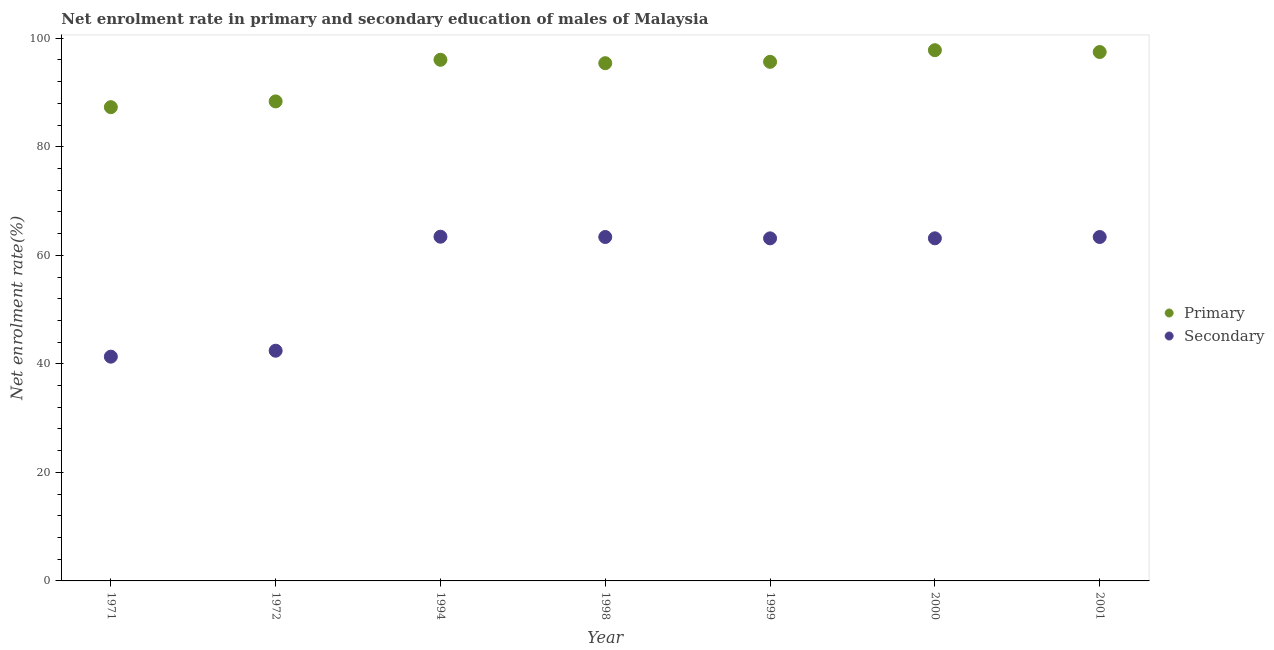Is the number of dotlines equal to the number of legend labels?
Provide a succinct answer. Yes. What is the enrollment rate in primary education in 1994?
Provide a short and direct response. 96.03. Across all years, what is the maximum enrollment rate in primary education?
Ensure brevity in your answer.  97.8. Across all years, what is the minimum enrollment rate in secondary education?
Your answer should be compact. 41.32. In which year was the enrollment rate in secondary education minimum?
Your answer should be very brief. 1971. What is the total enrollment rate in secondary education in the graph?
Offer a terse response. 400.18. What is the difference between the enrollment rate in primary education in 1972 and that in 1999?
Offer a very short reply. -7.29. What is the difference between the enrollment rate in secondary education in 1972 and the enrollment rate in primary education in 1994?
Your answer should be compact. -53.61. What is the average enrollment rate in primary education per year?
Give a very brief answer. 94. In the year 2001, what is the difference between the enrollment rate in primary education and enrollment rate in secondary education?
Keep it short and to the point. 34.09. What is the ratio of the enrollment rate in primary education in 1994 to that in 2001?
Give a very brief answer. 0.99. Is the enrollment rate in primary education in 1972 less than that in 1999?
Keep it short and to the point. Yes. Is the difference between the enrollment rate in primary education in 1998 and 1999 greater than the difference between the enrollment rate in secondary education in 1998 and 1999?
Ensure brevity in your answer.  No. What is the difference between the highest and the second highest enrollment rate in primary education?
Your answer should be compact. 0.34. What is the difference between the highest and the lowest enrollment rate in primary education?
Provide a short and direct response. 10.5. Does the graph contain any zero values?
Offer a terse response. No. Does the graph contain grids?
Provide a succinct answer. No. Where does the legend appear in the graph?
Offer a very short reply. Center right. How many legend labels are there?
Ensure brevity in your answer.  2. How are the legend labels stacked?
Your answer should be compact. Vertical. What is the title of the graph?
Give a very brief answer. Net enrolment rate in primary and secondary education of males of Malaysia. Does "Urban Population" appear as one of the legend labels in the graph?
Provide a short and direct response. No. What is the label or title of the X-axis?
Make the answer very short. Year. What is the label or title of the Y-axis?
Provide a short and direct response. Net enrolment rate(%). What is the Net enrolment rate(%) of Primary in 1971?
Keep it short and to the point. 87.3. What is the Net enrolment rate(%) of Secondary in 1971?
Offer a terse response. 41.32. What is the Net enrolment rate(%) in Primary in 1972?
Offer a terse response. 88.36. What is the Net enrolment rate(%) in Secondary in 1972?
Provide a succinct answer. 42.42. What is the Net enrolment rate(%) of Primary in 1994?
Offer a very short reply. 96.03. What is the Net enrolment rate(%) of Secondary in 1994?
Your answer should be compact. 63.43. What is the Net enrolment rate(%) of Primary in 1998?
Keep it short and to the point. 95.4. What is the Net enrolment rate(%) of Secondary in 1998?
Offer a very short reply. 63.38. What is the Net enrolment rate(%) of Primary in 1999?
Offer a terse response. 95.65. What is the Net enrolment rate(%) in Secondary in 1999?
Keep it short and to the point. 63.13. What is the Net enrolment rate(%) of Primary in 2000?
Give a very brief answer. 97.8. What is the Net enrolment rate(%) in Secondary in 2000?
Your answer should be compact. 63.13. What is the Net enrolment rate(%) in Primary in 2001?
Provide a succinct answer. 97.46. What is the Net enrolment rate(%) of Secondary in 2001?
Ensure brevity in your answer.  63.37. Across all years, what is the maximum Net enrolment rate(%) of Primary?
Give a very brief answer. 97.8. Across all years, what is the maximum Net enrolment rate(%) of Secondary?
Keep it short and to the point. 63.43. Across all years, what is the minimum Net enrolment rate(%) of Primary?
Keep it short and to the point. 87.3. Across all years, what is the minimum Net enrolment rate(%) of Secondary?
Your response must be concise. 41.32. What is the total Net enrolment rate(%) in Primary in the graph?
Your response must be concise. 658.01. What is the total Net enrolment rate(%) in Secondary in the graph?
Offer a very short reply. 400.18. What is the difference between the Net enrolment rate(%) in Primary in 1971 and that in 1972?
Offer a terse response. -1.06. What is the difference between the Net enrolment rate(%) in Secondary in 1971 and that in 1972?
Your answer should be very brief. -1.1. What is the difference between the Net enrolment rate(%) in Primary in 1971 and that in 1994?
Provide a succinct answer. -8.73. What is the difference between the Net enrolment rate(%) of Secondary in 1971 and that in 1994?
Keep it short and to the point. -22.11. What is the difference between the Net enrolment rate(%) in Primary in 1971 and that in 1998?
Make the answer very short. -8.1. What is the difference between the Net enrolment rate(%) of Secondary in 1971 and that in 1998?
Make the answer very short. -22.05. What is the difference between the Net enrolment rate(%) of Primary in 1971 and that in 1999?
Offer a very short reply. -8.36. What is the difference between the Net enrolment rate(%) in Secondary in 1971 and that in 1999?
Ensure brevity in your answer.  -21.8. What is the difference between the Net enrolment rate(%) of Primary in 1971 and that in 2000?
Provide a short and direct response. -10.5. What is the difference between the Net enrolment rate(%) of Secondary in 1971 and that in 2000?
Offer a very short reply. -21.81. What is the difference between the Net enrolment rate(%) of Primary in 1971 and that in 2001?
Provide a succinct answer. -10.16. What is the difference between the Net enrolment rate(%) of Secondary in 1971 and that in 2001?
Offer a very short reply. -22.05. What is the difference between the Net enrolment rate(%) of Primary in 1972 and that in 1994?
Provide a short and direct response. -7.67. What is the difference between the Net enrolment rate(%) in Secondary in 1972 and that in 1994?
Provide a succinct answer. -21.01. What is the difference between the Net enrolment rate(%) in Primary in 1972 and that in 1998?
Provide a succinct answer. -7.04. What is the difference between the Net enrolment rate(%) in Secondary in 1972 and that in 1998?
Offer a very short reply. -20.96. What is the difference between the Net enrolment rate(%) of Primary in 1972 and that in 1999?
Offer a very short reply. -7.29. What is the difference between the Net enrolment rate(%) in Secondary in 1972 and that in 1999?
Your response must be concise. -20.71. What is the difference between the Net enrolment rate(%) in Primary in 1972 and that in 2000?
Make the answer very short. -9.43. What is the difference between the Net enrolment rate(%) in Secondary in 1972 and that in 2000?
Your response must be concise. -20.71. What is the difference between the Net enrolment rate(%) of Primary in 1972 and that in 2001?
Provide a short and direct response. -9.1. What is the difference between the Net enrolment rate(%) of Secondary in 1972 and that in 2001?
Offer a terse response. -20.95. What is the difference between the Net enrolment rate(%) in Primary in 1994 and that in 1998?
Offer a terse response. 0.63. What is the difference between the Net enrolment rate(%) in Secondary in 1994 and that in 1998?
Ensure brevity in your answer.  0.05. What is the difference between the Net enrolment rate(%) in Primary in 1994 and that in 1999?
Your answer should be compact. 0.38. What is the difference between the Net enrolment rate(%) in Secondary in 1994 and that in 1999?
Give a very brief answer. 0.3. What is the difference between the Net enrolment rate(%) in Primary in 1994 and that in 2000?
Give a very brief answer. -1.77. What is the difference between the Net enrolment rate(%) in Secondary in 1994 and that in 2000?
Offer a very short reply. 0.3. What is the difference between the Net enrolment rate(%) of Primary in 1994 and that in 2001?
Your answer should be compact. -1.43. What is the difference between the Net enrolment rate(%) of Secondary in 1994 and that in 2001?
Offer a terse response. 0.06. What is the difference between the Net enrolment rate(%) of Primary in 1998 and that in 1999?
Provide a short and direct response. -0.25. What is the difference between the Net enrolment rate(%) in Secondary in 1998 and that in 1999?
Make the answer very short. 0.25. What is the difference between the Net enrolment rate(%) in Primary in 1998 and that in 2000?
Offer a terse response. -2.39. What is the difference between the Net enrolment rate(%) of Secondary in 1998 and that in 2000?
Provide a short and direct response. 0.24. What is the difference between the Net enrolment rate(%) of Primary in 1998 and that in 2001?
Keep it short and to the point. -2.06. What is the difference between the Net enrolment rate(%) in Secondary in 1998 and that in 2001?
Ensure brevity in your answer.  0. What is the difference between the Net enrolment rate(%) in Primary in 1999 and that in 2000?
Your answer should be compact. -2.14. What is the difference between the Net enrolment rate(%) of Secondary in 1999 and that in 2000?
Provide a short and direct response. -0.01. What is the difference between the Net enrolment rate(%) in Primary in 1999 and that in 2001?
Keep it short and to the point. -1.81. What is the difference between the Net enrolment rate(%) of Secondary in 1999 and that in 2001?
Give a very brief answer. -0.25. What is the difference between the Net enrolment rate(%) in Primary in 2000 and that in 2001?
Offer a terse response. 0.34. What is the difference between the Net enrolment rate(%) in Secondary in 2000 and that in 2001?
Provide a short and direct response. -0.24. What is the difference between the Net enrolment rate(%) of Primary in 1971 and the Net enrolment rate(%) of Secondary in 1972?
Keep it short and to the point. 44.88. What is the difference between the Net enrolment rate(%) of Primary in 1971 and the Net enrolment rate(%) of Secondary in 1994?
Ensure brevity in your answer.  23.87. What is the difference between the Net enrolment rate(%) of Primary in 1971 and the Net enrolment rate(%) of Secondary in 1998?
Make the answer very short. 23.92. What is the difference between the Net enrolment rate(%) in Primary in 1971 and the Net enrolment rate(%) in Secondary in 1999?
Give a very brief answer. 24.17. What is the difference between the Net enrolment rate(%) in Primary in 1971 and the Net enrolment rate(%) in Secondary in 2000?
Give a very brief answer. 24.17. What is the difference between the Net enrolment rate(%) in Primary in 1971 and the Net enrolment rate(%) in Secondary in 2001?
Provide a succinct answer. 23.92. What is the difference between the Net enrolment rate(%) in Primary in 1972 and the Net enrolment rate(%) in Secondary in 1994?
Ensure brevity in your answer.  24.93. What is the difference between the Net enrolment rate(%) in Primary in 1972 and the Net enrolment rate(%) in Secondary in 1998?
Provide a succinct answer. 24.99. What is the difference between the Net enrolment rate(%) of Primary in 1972 and the Net enrolment rate(%) of Secondary in 1999?
Give a very brief answer. 25.24. What is the difference between the Net enrolment rate(%) of Primary in 1972 and the Net enrolment rate(%) of Secondary in 2000?
Offer a terse response. 25.23. What is the difference between the Net enrolment rate(%) of Primary in 1972 and the Net enrolment rate(%) of Secondary in 2001?
Keep it short and to the point. 24.99. What is the difference between the Net enrolment rate(%) of Primary in 1994 and the Net enrolment rate(%) of Secondary in 1998?
Your response must be concise. 32.66. What is the difference between the Net enrolment rate(%) of Primary in 1994 and the Net enrolment rate(%) of Secondary in 1999?
Your response must be concise. 32.9. What is the difference between the Net enrolment rate(%) of Primary in 1994 and the Net enrolment rate(%) of Secondary in 2000?
Your answer should be compact. 32.9. What is the difference between the Net enrolment rate(%) in Primary in 1994 and the Net enrolment rate(%) in Secondary in 2001?
Provide a succinct answer. 32.66. What is the difference between the Net enrolment rate(%) in Primary in 1998 and the Net enrolment rate(%) in Secondary in 1999?
Provide a short and direct response. 32.28. What is the difference between the Net enrolment rate(%) of Primary in 1998 and the Net enrolment rate(%) of Secondary in 2000?
Provide a short and direct response. 32.27. What is the difference between the Net enrolment rate(%) of Primary in 1998 and the Net enrolment rate(%) of Secondary in 2001?
Provide a short and direct response. 32.03. What is the difference between the Net enrolment rate(%) in Primary in 1999 and the Net enrolment rate(%) in Secondary in 2000?
Your response must be concise. 32.52. What is the difference between the Net enrolment rate(%) in Primary in 1999 and the Net enrolment rate(%) in Secondary in 2001?
Offer a terse response. 32.28. What is the difference between the Net enrolment rate(%) in Primary in 2000 and the Net enrolment rate(%) in Secondary in 2001?
Offer a very short reply. 34.42. What is the average Net enrolment rate(%) of Primary per year?
Offer a very short reply. 94. What is the average Net enrolment rate(%) of Secondary per year?
Offer a terse response. 57.17. In the year 1971, what is the difference between the Net enrolment rate(%) in Primary and Net enrolment rate(%) in Secondary?
Make the answer very short. 45.98. In the year 1972, what is the difference between the Net enrolment rate(%) of Primary and Net enrolment rate(%) of Secondary?
Your response must be concise. 45.94. In the year 1994, what is the difference between the Net enrolment rate(%) of Primary and Net enrolment rate(%) of Secondary?
Keep it short and to the point. 32.6. In the year 1998, what is the difference between the Net enrolment rate(%) in Primary and Net enrolment rate(%) in Secondary?
Your response must be concise. 32.03. In the year 1999, what is the difference between the Net enrolment rate(%) in Primary and Net enrolment rate(%) in Secondary?
Keep it short and to the point. 32.53. In the year 2000, what is the difference between the Net enrolment rate(%) of Primary and Net enrolment rate(%) of Secondary?
Give a very brief answer. 34.66. In the year 2001, what is the difference between the Net enrolment rate(%) of Primary and Net enrolment rate(%) of Secondary?
Give a very brief answer. 34.09. What is the ratio of the Net enrolment rate(%) of Secondary in 1971 to that in 1972?
Offer a terse response. 0.97. What is the ratio of the Net enrolment rate(%) in Primary in 1971 to that in 1994?
Your answer should be very brief. 0.91. What is the ratio of the Net enrolment rate(%) in Secondary in 1971 to that in 1994?
Give a very brief answer. 0.65. What is the ratio of the Net enrolment rate(%) in Primary in 1971 to that in 1998?
Your answer should be compact. 0.92. What is the ratio of the Net enrolment rate(%) of Secondary in 1971 to that in 1998?
Offer a terse response. 0.65. What is the ratio of the Net enrolment rate(%) of Primary in 1971 to that in 1999?
Ensure brevity in your answer.  0.91. What is the ratio of the Net enrolment rate(%) in Secondary in 1971 to that in 1999?
Offer a terse response. 0.65. What is the ratio of the Net enrolment rate(%) of Primary in 1971 to that in 2000?
Your answer should be very brief. 0.89. What is the ratio of the Net enrolment rate(%) in Secondary in 1971 to that in 2000?
Your answer should be compact. 0.65. What is the ratio of the Net enrolment rate(%) in Primary in 1971 to that in 2001?
Ensure brevity in your answer.  0.9. What is the ratio of the Net enrolment rate(%) of Secondary in 1971 to that in 2001?
Keep it short and to the point. 0.65. What is the ratio of the Net enrolment rate(%) of Primary in 1972 to that in 1994?
Ensure brevity in your answer.  0.92. What is the ratio of the Net enrolment rate(%) in Secondary in 1972 to that in 1994?
Your response must be concise. 0.67. What is the ratio of the Net enrolment rate(%) in Primary in 1972 to that in 1998?
Provide a short and direct response. 0.93. What is the ratio of the Net enrolment rate(%) of Secondary in 1972 to that in 1998?
Your answer should be very brief. 0.67. What is the ratio of the Net enrolment rate(%) of Primary in 1972 to that in 1999?
Ensure brevity in your answer.  0.92. What is the ratio of the Net enrolment rate(%) in Secondary in 1972 to that in 1999?
Your response must be concise. 0.67. What is the ratio of the Net enrolment rate(%) of Primary in 1972 to that in 2000?
Offer a very short reply. 0.9. What is the ratio of the Net enrolment rate(%) of Secondary in 1972 to that in 2000?
Your response must be concise. 0.67. What is the ratio of the Net enrolment rate(%) in Primary in 1972 to that in 2001?
Your answer should be compact. 0.91. What is the ratio of the Net enrolment rate(%) in Secondary in 1972 to that in 2001?
Give a very brief answer. 0.67. What is the ratio of the Net enrolment rate(%) in Primary in 1994 to that in 1998?
Provide a succinct answer. 1.01. What is the ratio of the Net enrolment rate(%) in Secondary in 1994 to that in 1999?
Provide a succinct answer. 1. What is the ratio of the Net enrolment rate(%) of Primary in 1994 to that in 2000?
Keep it short and to the point. 0.98. What is the ratio of the Net enrolment rate(%) of Secondary in 1994 to that in 2000?
Keep it short and to the point. 1. What is the ratio of the Net enrolment rate(%) of Primary in 1998 to that in 1999?
Keep it short and to the point. 1. What is the ratio of the Net enrolment rate(%) of Secondary in 1998 to that in 1999?
Provide a succinct answer. 1. What is the ratio of the Net enrolment rate(%) in Primary in 1998 to that in 2000?
Your response must be concise. 0.98. What is the ratio of the Net enrolment rate(%) in Secondary in 1998 to that in 2000?
Provide a succinct answer. 1. What is the ratio of the Net enrolment rate(%) of Primary in 1998 to that in 2001?
Keep it short and to the point. 0.98. What is the ratio of the Net enrolment rate(%) in Primary in 1999 to that in 2000?
Your answer should be compact. 0.98. What is the ratio of the Net enrolment rate(%) in Primary in 1999 to that in 2001?
Provide a succinct answer. 0.98. What is the ratio of the Net enrolment rate(%) in Secondary in 2000 to that in 2001?
Offer a very short reply. 1. What is the difference between the highest and the second highest Net enrolment rate(%) of Primary?
Give a very brief answer. 0.34. What is the difference between the highest and the second highest Net enrolment rate(%) in Secondary?
Make the answer very short. 0.05. What is the difference between the highest and the lowest Net enrolment rate(%) of Primary?
Give a very brief answer. 10.5. What is the difference between the highest and the lowest Net enrolment rate(%) in Secondary?
Keep it short and to the point. 22.11. 